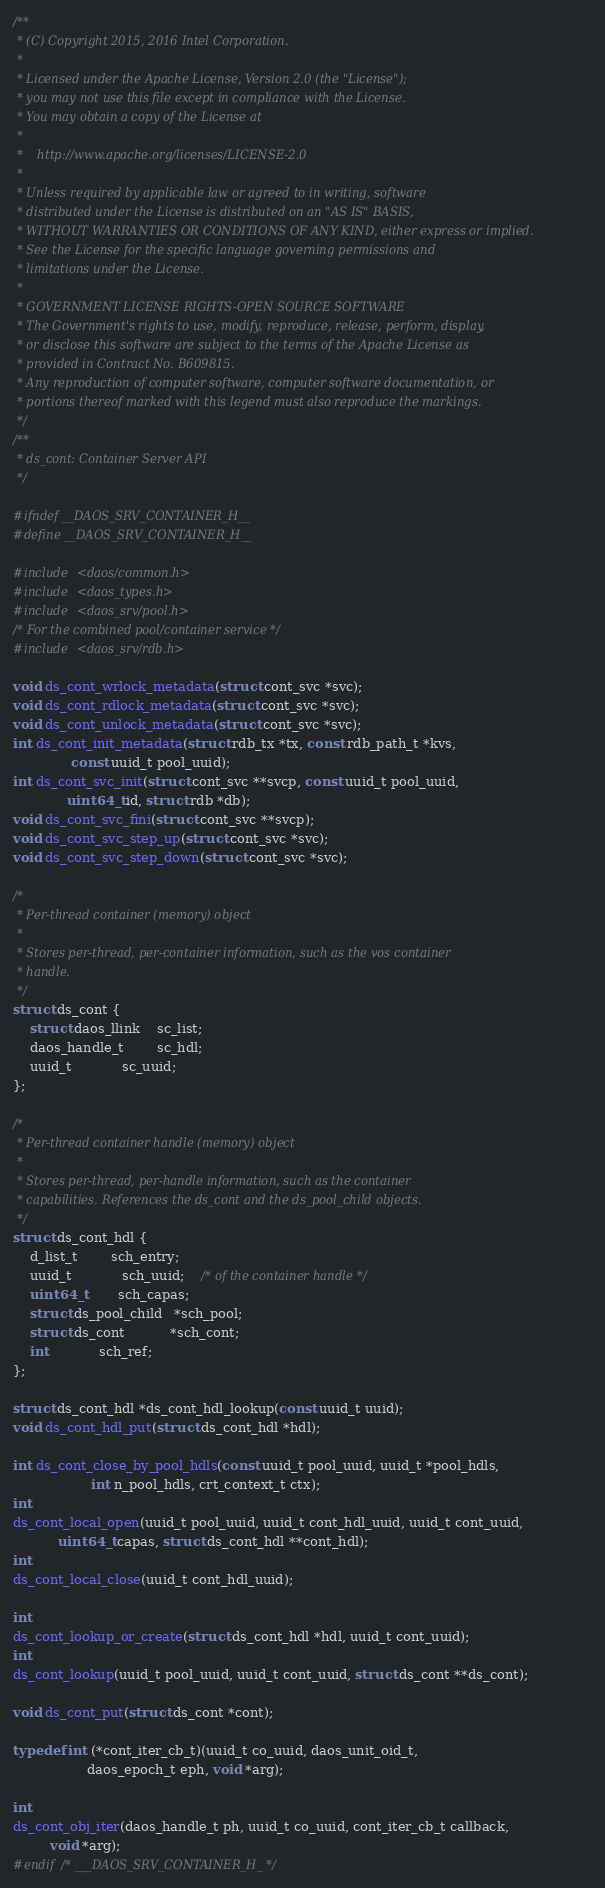Convert code to text. <code><loc_0><loc_0><loc_500><loc_500><_C_>/**
 * (C) Copyright 2015, 2016 Intel Corporation.
 *
 * Licensed under the Apache License, Version 2.0 (the "License");
 * you may not use this file except in compliance with the License.
 * You may obtain a copy of the License at
 *
 *    http://www.apache.org/licenses/LICENSE-2.0
 *
 * Unless required by applicable law or agreed to in writing, software
 * distributed under the License is distributed on an "AS IS" BASIS,
 * WITHOUT WARRANTIES OR CONDITIONS OF ANY KIND, either express or implied.
 * See the License for the specific language governing permissions and
 * limitations under the License.
 *
 * GOVERNMENT LICENSE RIGHTS-OPEN SOURCE SOFTWARE
 * The Government's rights to use, modify, reproduce, release, perform, display,
 * or disclose this software are subject to the terms of the Apache License as
 * provided in Contract No. B609815.
 * Any reproduction of computer software, computer software documentation, or
 * portions thereof marked with this legend must also reproduce the markings.
 */
/**
 * ds_cont: Container Server API
 */

#ifndef __DAOS_SRV_CONTAINER_H__
#define __DAOS_SRV_CONTAINER_H__

#include <daos/common.h>
#include <daos_types.h>
#include <daos_srv/pool.h>
/* For the combined pool/container service */
#include <daos_srv/rdb.h>

void ds_cont_wrlock_metadata(struct cont_svc *svc);
void ds_cont_rdlock_metadata(struct cont_svc *svc);
void ds_cont_unlock_metadata(struct cont_svc *svc);
int ds_cont_init_metadata(struct rdb_tx *tx, const rdb_path_t *kvs,
			  const uuid_t pool_uuid);
int ds_cont_svc_init(struct cont_svc **svcp, const uuid_t pool_uuid,
		     uint64_t id, struct rdb *db);
void ds_cont_svc_fini(struct cont_svc **svcp);
void ds_cont_svc_step_up(struct cont_svc *svc);
void ds_cont_svc_step_down(struct cont_svc *svc);

/*
 * Per-thread container (memory) object
 *
 * Stores per-thread, per-container information, such as the vos container
 * handle.
 */
struct ds_cont {
	struct daos_llink	sc_list;
	daos_handle_t		sc_hdl;
	uuid_t			sc_uuid;
};

/*
 * Per-thread container handle (memory) object
 *
 * Stores per-thread, per-handle information, such as the container
 * capabilities. References the ds_cont and the ds_pool_child objects.
 */
struct ds_cont_hdl {
	d_list_t		sch_entry;
	uuid_t			sch_uuid;	/* of the container handle */
	uint64_t		sch_capas;
	struct ds_pool_child   *sch_pool;
	struct ds_cont	       *sch_cont;
	int			sch_ref;
};

struct ds_cont_hdl *ds_cont_hdl_lookup(const uuid_t uuid);
void ds_cont_hdl_put(struct ds_cont_hdl *hdl);

int ds_cont_close_by_pool_hdls(const uuid_t pool_uuid, uuid_t *pool_hdls,
			       int n_pool_hdls, crt_context_t ctx);
int
ds_cont_local_open(uuid_t pool_uuid, uuid_t cont_hdl_uuid, uuid_t cont_uuid,
		   uint64_t capas, struct ds_cont_hdl **cont_hdl);
int
ds_cont_local_close(uuid_t cont_hdl_uuid);

int
ds_cont_lookup_or_create(struct ds_cont_hdl *hdl, uuid_t cont_uuid);
int
ds_cont_lookup(uuid_t pool_uuid, uuid_t cont_uuid, struct ds_cont **ds_cont);

void ds_cont_put(struct ds_cont *cont);

typedef int (*cont_iter_cb_t)(uuid_t co_uuid, daos_unit_oid_t,
			      daos_epoch_t eph, void *arg);

int
ds_cont_obj_iter(daos_handle_t ph, uuid_t co_uuid, cont_iter_cb_t callback,
		 void *arg);
#endif /* ___DAOS_SRV_CONTAINER_H_ */
</code> 